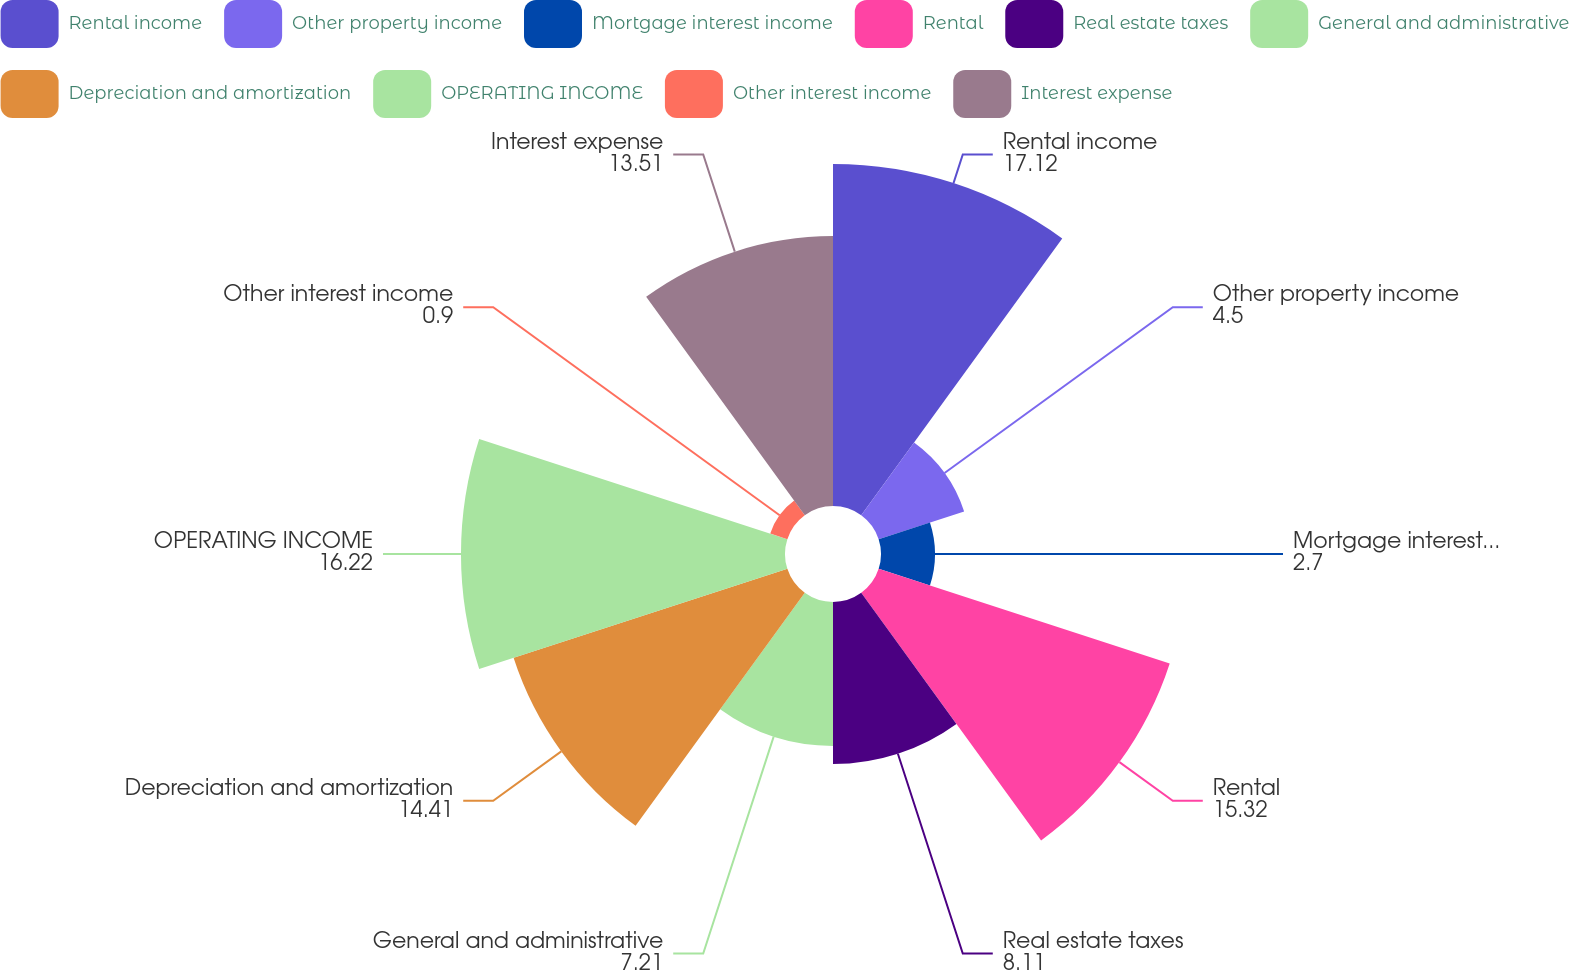Convert chart to OTSL. <chart><loc_0><loc_0><loc_500><loc_500><pie_chart><fcel>Rental income<fcel>Other property income<fcel>Mortgage interest income<fcel>Rental<fcel>Real estate taxes<fcel>General and administrative<fcel>Depreciation and amortization<fcel>OPERATING INCOME<fcel>Other interest income<fcel>Interest expense<nl><fcel>17.12%<fcel>4.5%<fcel>2.7%<fcel>15.32%<fcel>8.11%<fcel>7.21%<fcel>14.41%<fcel>16.22%<fcel>0.9%<fcel>13.51%<nl></chart> 